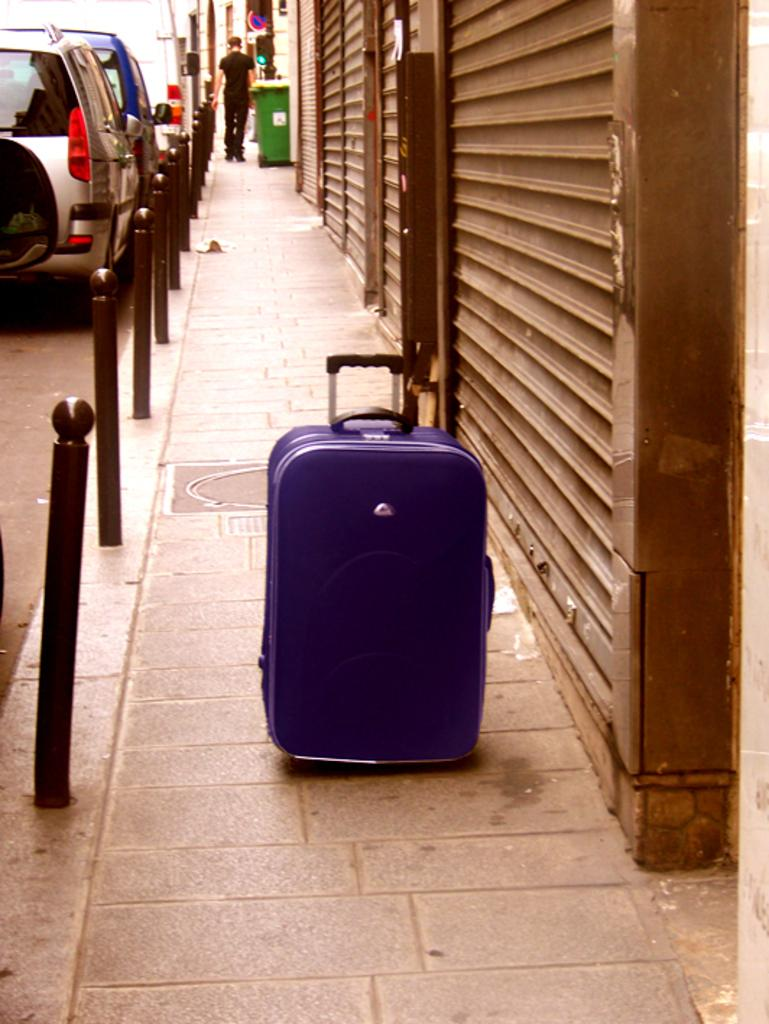What object can be seen in the image that is commonly used for carrying items? There is a briefcase in the image. What can be seen moving on the road in the image? There are cars on the road in the image. What is the man in the image doing? The man is standing on the road in the image. What type of container is present in the image? There is a bin in the image. What is the taste of the money in the image? There is no money present in the image, so it is not possible to determine its taste. 